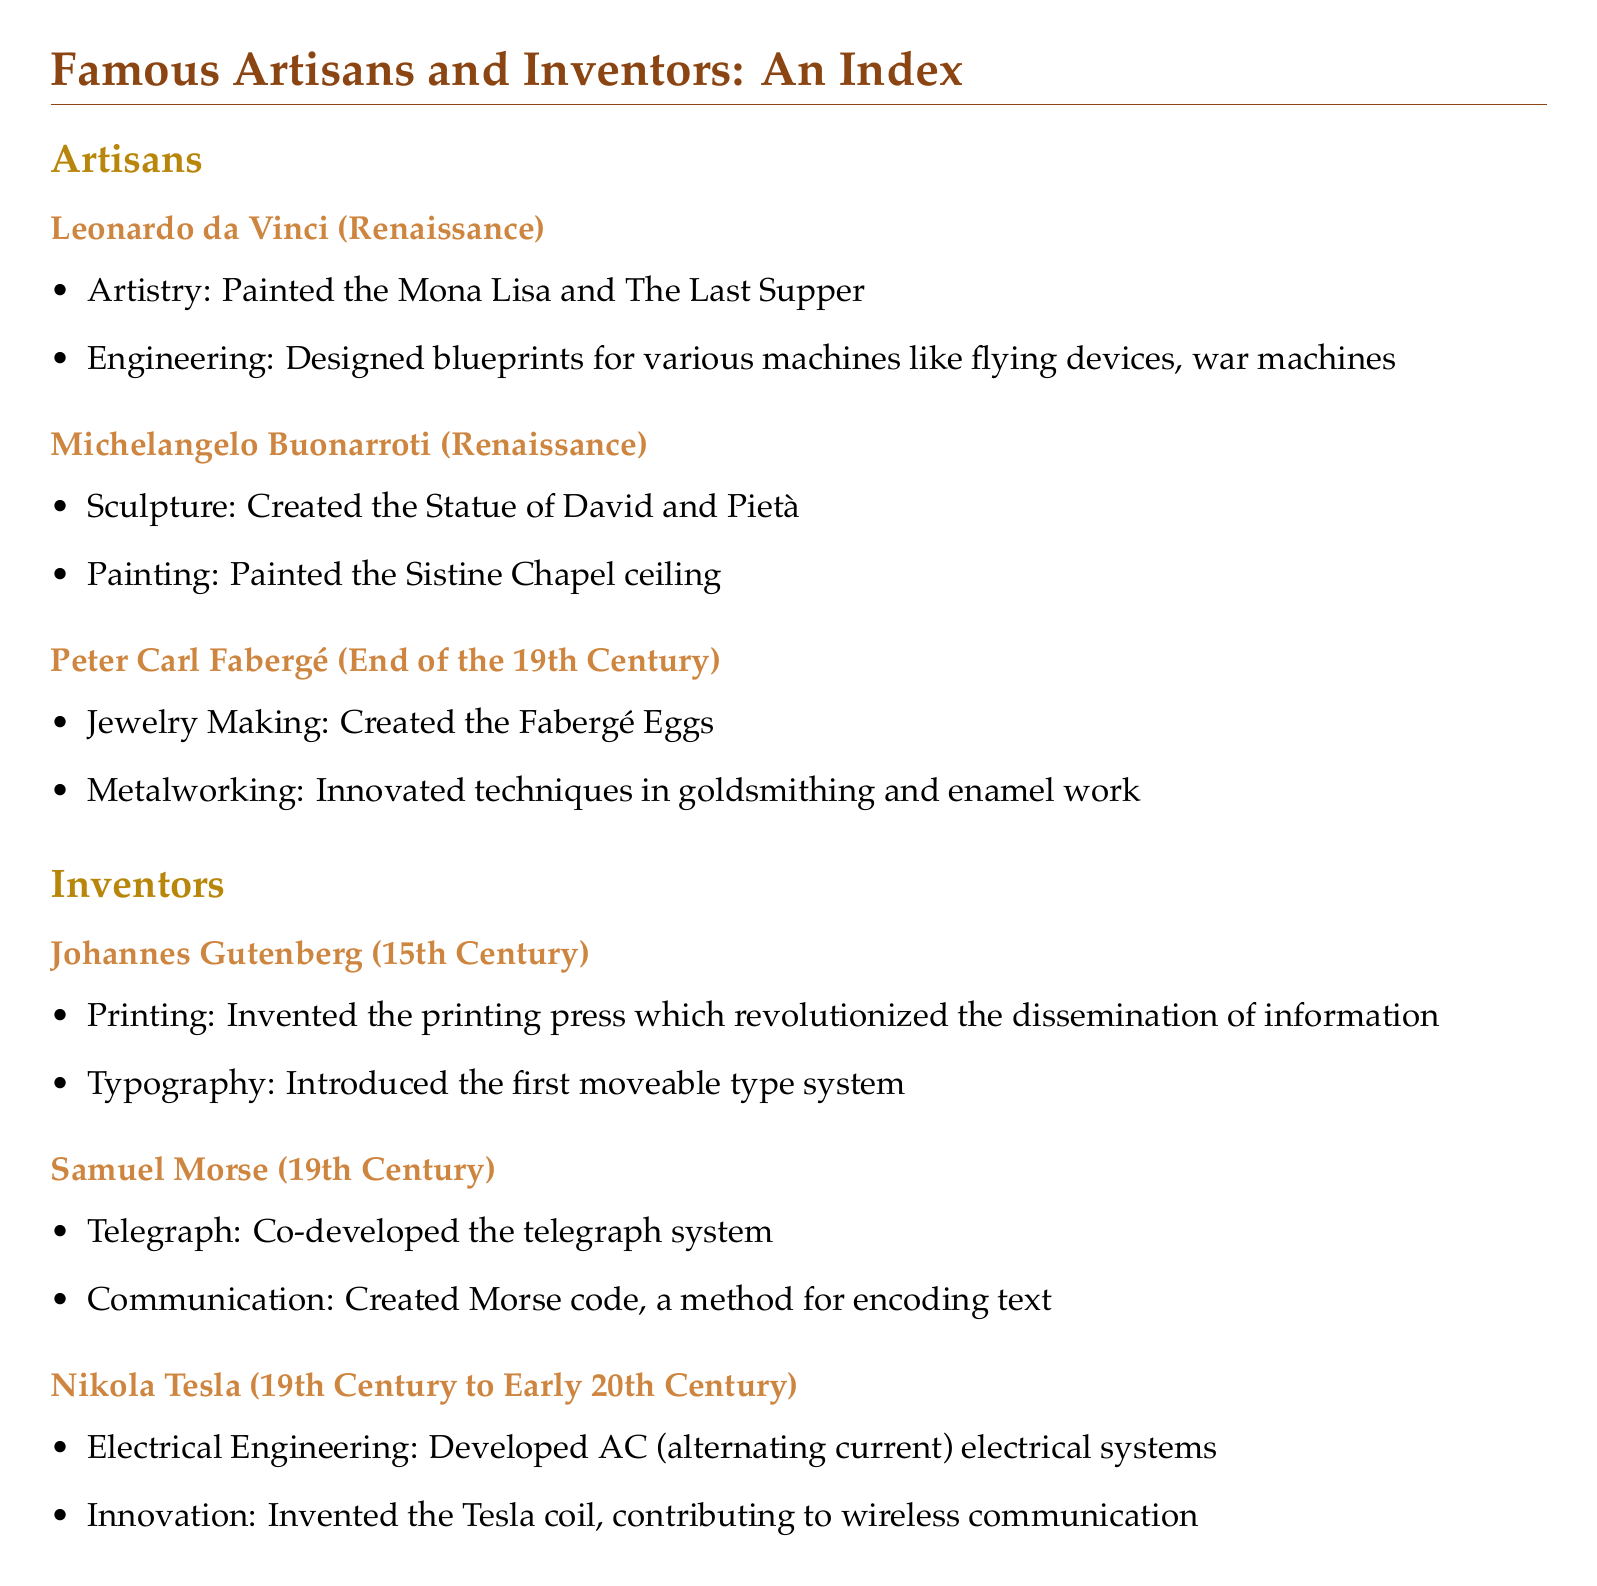What are the professions of Leonardo da Vinci? The document lists artistry and engineering as Leonardo da Vinci's professions.
Answer: Artistry, Engineering What was Michelangelo's notable painting work? The document mentions the Sistine Chapel ceiling as a notable painting of Michelangelo.
Answer: Sistine Chapel ceiling Which invention is Johannes Gutenberg most famous for? According to the document, Johannes Gutenberg is most famous for inventing the printing press.
Answer: Printing press What is the primary contribution of Nikola Tesla mentioned in the document? Nikola Tesla's primary contribution noted in the document is the development of AC electrical systems.
Answer: AC electrical systems What technique did Peter Carl Fabergé innovate? The document states that Peter Carl Fabergé innovated techniques in goldsmithing and enamel work.
Answer: Goldsmithing and enamel work In what century did Samuel Morse make significant contributions? The document indicates that Samuel Morse made contributions in the 19th century.
Answer: 19th Century Which two notable figures are categorized as artisans in the document? The artisans mentioned in the document are Leonardo da Vinci and Michelangelo Buonarroti.
Answer: Leonardo da Vinci, Michelangelo Buonarroti What is the significance of Morse code as described in the document? The document describes Morse code as a method for encoding text as part of Samuel Morse's contributions.
Answer: Method for encoding text Which two categories are used to organize the index in the document? The document categorizes the index into artisans and inventors.
Answer: Artisans, Inventors 